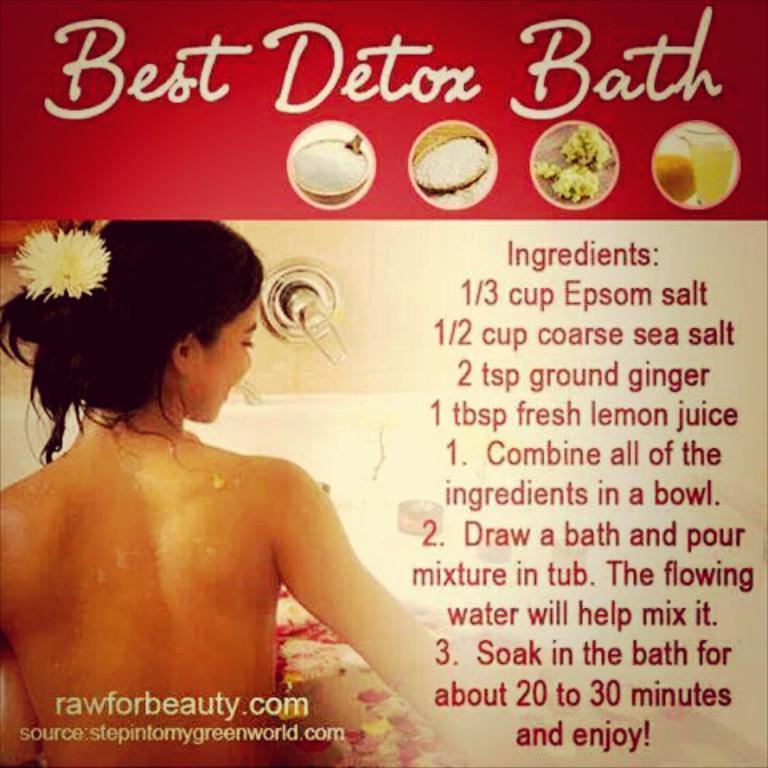In one or two sentences, can you explain what this image depicts? In this image we can see a poster with some text and depiction of a person. 